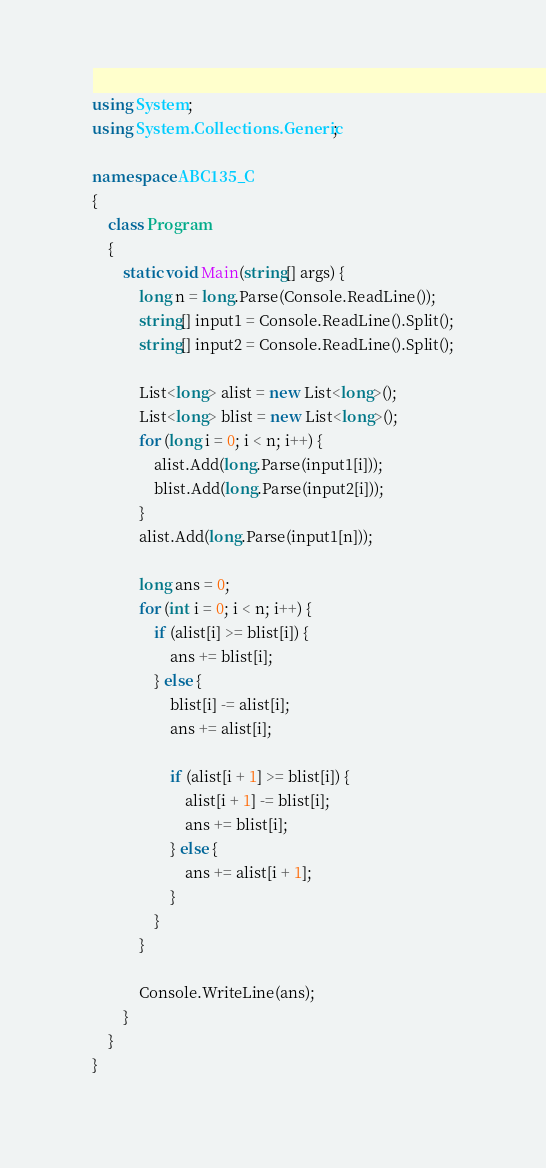Convert code to text. <code><loc_0><loc_0><loc_500><loc_500><_C#_>using System;
using System.Collections.Generic;

namespace ABC135_C
{
    class Program
    {
        static void Main(string[] args) {
            long n = long.Parse(Console.ReadLine());
            string[] input1 = Console.ReadLine().Split();
            string[] input2 = Console.ReadLine().Split();

            List<long> alist = new List<long>();
            List<long> blist = new List<long>();
            for (long i = 0; i < n; i++) {
                alist.Add(long.Parse(input1[i]));
                blist.Add(long.Parse(input2[i]));
            }
            alist.Add(long.Parse(input1[n]));

            long ans = 0;
            for (int i = 0; i < n; i++) {
                if (alist[i] >= blist[i]) {
                    ans += blist[i];
                } else {
                    blist[i] -= alist[i];
                    ans += alist[i];

                    if (alist[i + 1] >= blist[i]) {
                        alist[i + 1] -= blist[i];
                        ans += blist[i];
                    } else {
                        ans += alist[i + 1];
                    }
                }
            }

            Console.WriteLine(ans);
        }
    }
}</code> 